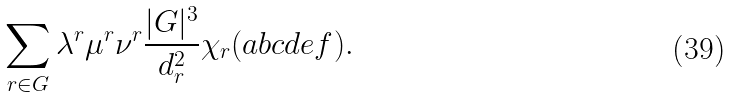Convert formula to latex. <formula><loc_0><loc_0><loc_500><loc_500>\sum _ { r \in G } \lambda ^ { r } \mu ^ { r } \nu ^ { r } \frac { | G | ^ { 3 } } { d _ { r } ^ { 2 } } \chi _ { r } ( a b c d e f ) .</formula> 